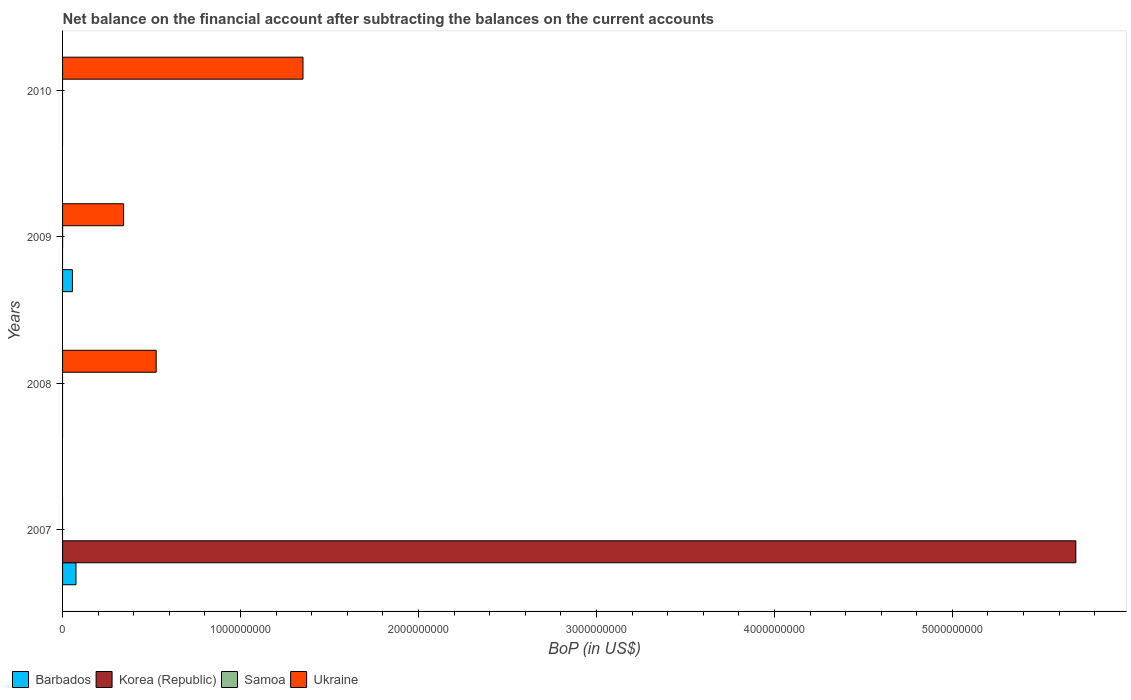How many different coloured bars are there?
Provide a succinct answer. 4. In how many cases, is the number of bars for a given year not equal to the number of legend labels?
Provide a short and direct response. 4. What is the Balance of Payments in Ukraine in 2009?
Offer a terse response. 3.43e+08. Across all years, what is the maximum Balance of Payments in Barbados?
Ensure brevity in your answer.  7.55e+07. Across all years, what is the minimum Balance of Payments in Barbados?
Your response must be concise. 0. What is the total Balance of Payments in Korea (Republic) in the graph?
Ensure brevity in your answer.  5.69e+09. What is the difference between the Balance of Payments in Ukraine in 2009 and that in 2010?
Give a very brief answer. -1.01e+09. What is the average Balance of Payments in Korea (Republic) per year?
Give a very brief answer. 1.42e+09. In the year 2007, what is the difference between the Balance of Payments in Barbados and Balance of Payments in Korea (Republic)?
Your answer should be very brief. -5.62e+09. What is the difference between the highest and the second highest Balance of Payments in Ukraine?
Offer a terse response. 8.25e+08. What is the difference between the highest and the lowest Balance of Payments in Ukraine?
Your response must be concise. 1.35e+09. Is it the case that in every year, the sum of the Balance of Payments in Korea (Republic) and Balance of Payments in Ukraine is greater than the sum of Balance of Payments in Samoa and Balance of Payments in Barbados?
Your answer should be compact. Yes. Is it the case that in every year, the sum of the Balance of Payments in Ukraine and Balance of Payments in Barbados is greater than the Balance of Payments in Korea (Republic)?
Keep it short and to the point. No. Are all the bars in the graph horizontal?
Keep it short and to the point. Yes. Are the values on the major ticks of X-axis written in scientific E-notation?
Your answer should be very brief. No. Does the graph contain any zero values?
Ensure brevity in your answer.  Yes. Where does the legend appear in the graph?
Provide a short and direct response. Bottom left. How many legend labels are there?
Give a very brief answer. 4. What is the title of the graph?
Your answer should be very brief. Net balance on the financial account after subtracting the balances on the current accounts. Does "Sub-Saharan Africa (developing only)" appear as one of the legend labels in the graph?
Your response must be concise. No. What is the label or title of the X-axis?
Make the answer very short. BoP (in US$). What is the label or title of the Y-axis?
Make the answer very short. Years. What is the BoP (in US$) of Barbados in 2007?
Give a very brief answer. 7.55e+07. What is the BoP (in US$) of Korea (Republic) in 2007?
Give a very brief answer. 5.69e+09. What is the BoP (in US$) in Samoa in 2007?
Offer a very short reply. 0. What is the BoP (in US$) in Samoa in 2008?
Make the answer very short. 0. What is the BoP (in US$) in Ukraine in 2008?
Provide a short and direct response. 5.26e+08. What is the BoP (in US$) of Barbados in 2009?
Give a very brief answer. 5.54e+07. What is the BoP (in US$) in Samoa in 2009?
Offer a very short reply. 2.61e+05. What is the BoP (in US$) in Ukraine in 2009?
Your answer should be compact. 3.43e+08. What is the BoP (in US$) in Korea (Republic) in 2010?
Provide a succinct answer. 0. What is the BoP (in US$) of Samoa in 2010?
Offer a terse response. 0. What is the BoP (in US$) of Ukraine in 2010?
Give a very brief answer. 1.35e+09. Across all years, what is the maximum BoP (in US$) in Barbados?
Provide a succinct answer. 7.55e+07. Across all years, what is the maximum BoP (in US$) in Korea (Republic)?
Offer a terse response. 5.69e+09. Across all years, what is the maximum BoP (in US$) of Samoa?
Provide a succinct answer. 2.61e+05. Across all years, what is the maximum BoP (in US$) of Ukraine?
Ensure brevity in your answer.  1.35e+09. Across all years, what is the minimum BoP (in US$) of Ukraine?
Your response must be concise. 0. What is the total BoP (in US$) in Barbados in the graph?
Provide a short and direct response. 1.31e+08. What is the total BoP (in US$) of Korea (Republic) in the graph?
Give a very brief answer. 5.69e+09. What is the total BoP (in US$) of Samoa in the graph?
Keep it short and to the point. 2.61e+05. What is the total BoP (in US$) of Ukraine in the graph?
Offer a very short reply. 2.22e+09. What is the difference between the BoP (in US$) of Barbados in 2007 and that in 2009?
Your answer should be compact. 2.01e+07. What is the difference between the BoP (in US$) in Ukraine in 2008 and that in 2009?
Provide a short and direct response. 1.83e+08. What is the difference between the BoP (in US$) in Ukraine in 2008 and that in 2010?
Offer a terse response. -8.25e+08. What is the difference between the BoP (in US$) of Ukraine in 2009 and that in 2010?
Provide a short and direct response. -1.01e+09. What is the difference between the BoP (in US$) in Barbados in 2007 and the BoP (in US$) in Ukraine in 2008?
Provide a short and direct response. -4.50e+08. What is the difference between the BoP (in US$) of Korea (Republic) in 2007 and the BoP (in US$) of Ukraine in 2008?
Keep it short and to the point. 5.17e+09. What is the difference between the BoP (in US$) in Barbados in 2007 and the BoP (in US$) in Samoa in 2009?
Your answer should be compact. 7.53e+07. What is the difference between the BoP (in US$) of Barbados in 2007 and the BoP (in US$) of Ukraine in 2009?
Ensure brevity in your answer.  -2.67e+08. What is the difference between the BoP (in US$) in Korea (Republic) in 2007 and the BoP (in US$) in Samoa in 2009?
Give a very brief answer. 5.69e+09. What is the difference between the BoP (in US$) in Korea (Republic) in 2007 and the BoP (in US$) in Ukraine in 2009?
Provide a short and direct response. 5.35e+09. What is the difference between the BoP (in US$) of Barbados in 2007 and the BoP (in US$) of Ukraine in 2010?
Provide a short and direct response. -1.28e+09. What is the difference between the BoP (in US$) in Korea (Republic) in 2007 and the BoP (in US$) in Ukraine in 2010?
Your response must be concise. 4.34e+09. What is the difference between the BoP (in US$) in Barbados in 2009 and the BoP (in US$) in Ukraine in 2010?
Ensure brevity in your answer.  -1.30e+09. What is the difference between the BoP (in US$) in Samoa in 2009 and the BoP (in US$) in Ukraine in 2010?
Your response must be concise. -1.35e+09. What is the average BoP (in US$) of Barbados per year?
Give a very brief answer. 3.27e+07. What is the average BoP (in US$) of Korea (Republic) per year?
Offer a terse response. 1.42e+09. What is the average BoP (in US$) in Samoa per year?
Give a very brief answer. 6.53e+04. What is the average BoP (in US$) of Ukraine per year?
Provide a succinct answer. 5.55e+08. In the year 2007, what is the difference between the BoP (in US$) in Barbados and BoP (in US$) in Korea (Republic)?
Provide a succinct answer. -5.62e+09. In the year 2009, what is the difference between the BoP (in US$) in Barbados and BoP (in US$) in Samoa?
Give a very brief answer. 5.51e+07. In the year 2009, what is the difference between the BoP (in US$) in Barbados and BoP (in US$) in Ukraine?
Provide a succinct answer. -2.88e+08. In the year 2009, what is the difference between the BoP (in US$) of Samoa and BoP (in US$) of Ukraine?
Make the answer very short. -3.43e+08. What is the ratio of the BoP (in US$) of Barbados in 2007 to that in 2009?
Offer a very short reply. 1.36. What is the ratio of the BoP (in US$) in Ukraine in 2008 to that in 2009?
Offer a terse response. 1.53. What is the ratio of the BoP (in US$) in Ukraine in 2008 to that in 2010?
Offer a very short reply. 0.39. What is the ratio of the BoP (in US$) of Ukraine in 2009 to that in 2010?
Make the answer very short. 0.25. What is the difference between the highest and the second highest BoP (in US$) of Ukraine?
Your answer should be compact. 8.25e+08. What is the difference between the highest and the lowest BoP (in US$) of Barbados?
Your answer should be compact. 7.55e+07. What is the difference between the highest and the lowest BoP (in US$) of Korea (Republic)?
Provide a succinct answer. 5.69e+09. What is the difference between the highest and the lowest BoP (in US$) of Samoa?
Your response must be concise. 2.61e+05. What is the difference between the highest and the lowest BoP (in US$) in Ukraine?
Your response must be concise. 1.35e+09. 